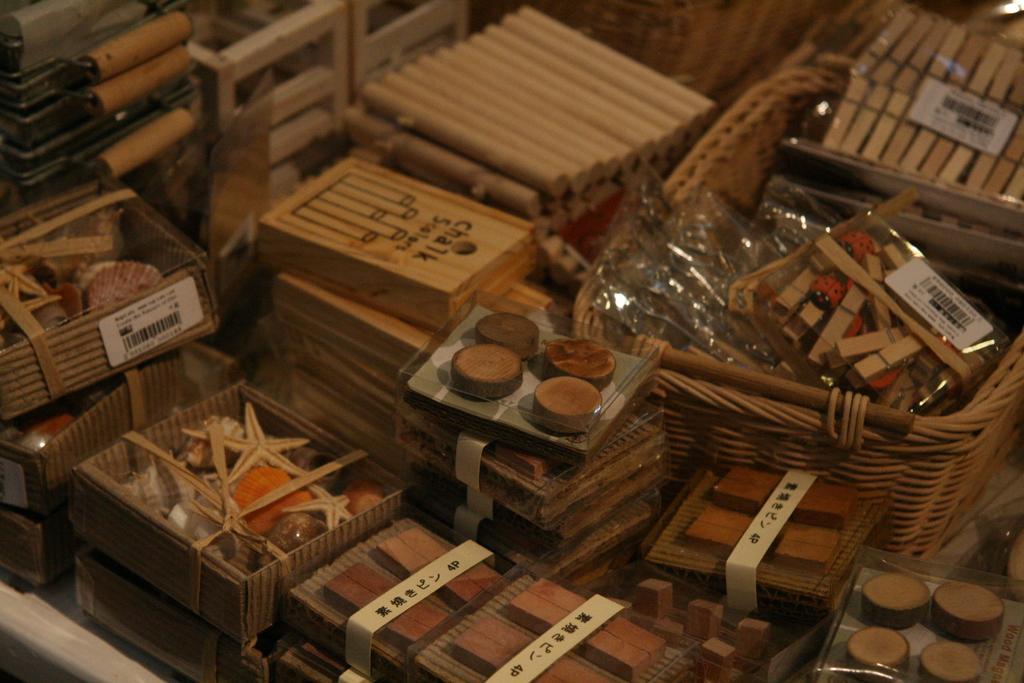Can you describe this image briefly? In the center of the image we can see sticks, clips, wooden boxes, wooden pieces, stickers on a few objects and a few other objects. 